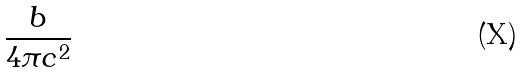<formula> <loc_0><loc_0><loc_500><loc_500>\frac { b } { 4 \pi c ^ { 2 } }</formula> 